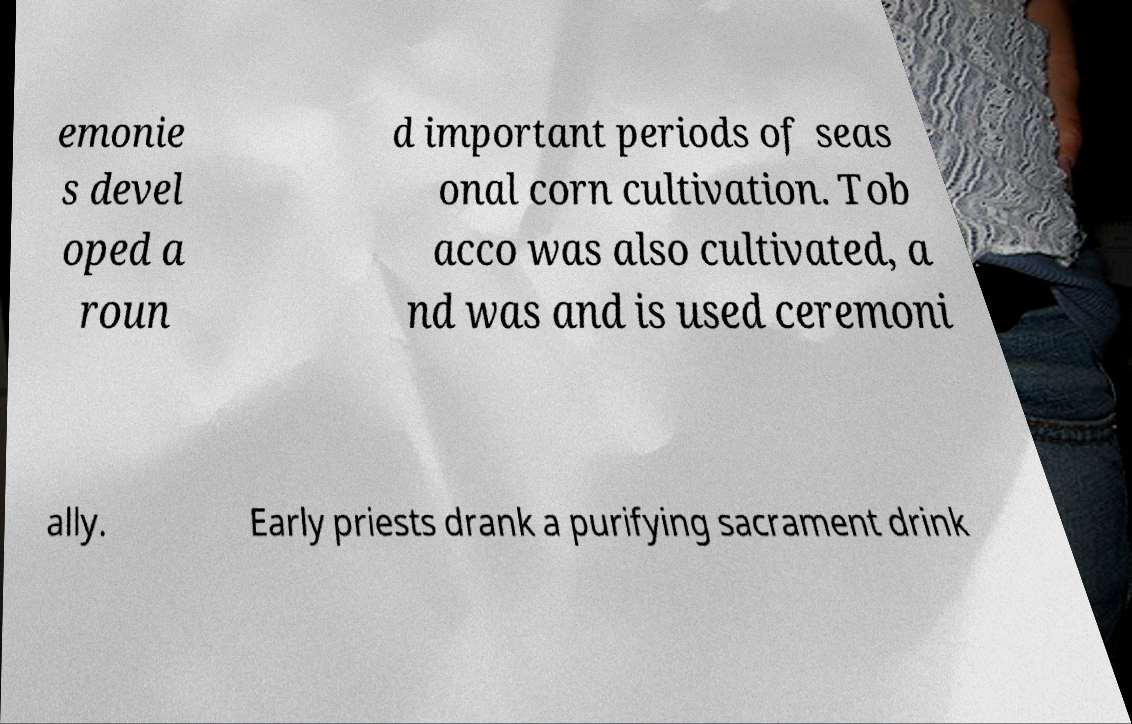I need the written content from this picture converted into text. Can you do that? emonie s devel oped a roun d important periods of seas onal corn cultivation. Tob acco was also cultivated, a nd was and is used ceremoni ally. Early priests drank a purifying sacrament drink 